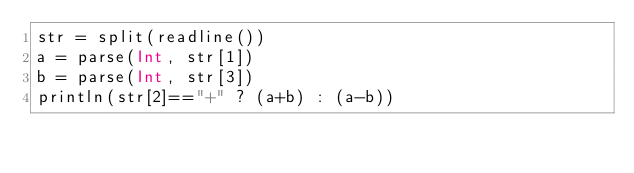Convert code to text. <code><loc_0><loc_0><loc_500><loc_500><_Julia_>str = split(readline())
a = parse(Int, str[1])
b = parse(Int, str[3])
println(str[2]=="+" ? (a+b) : (a-b))</code> 